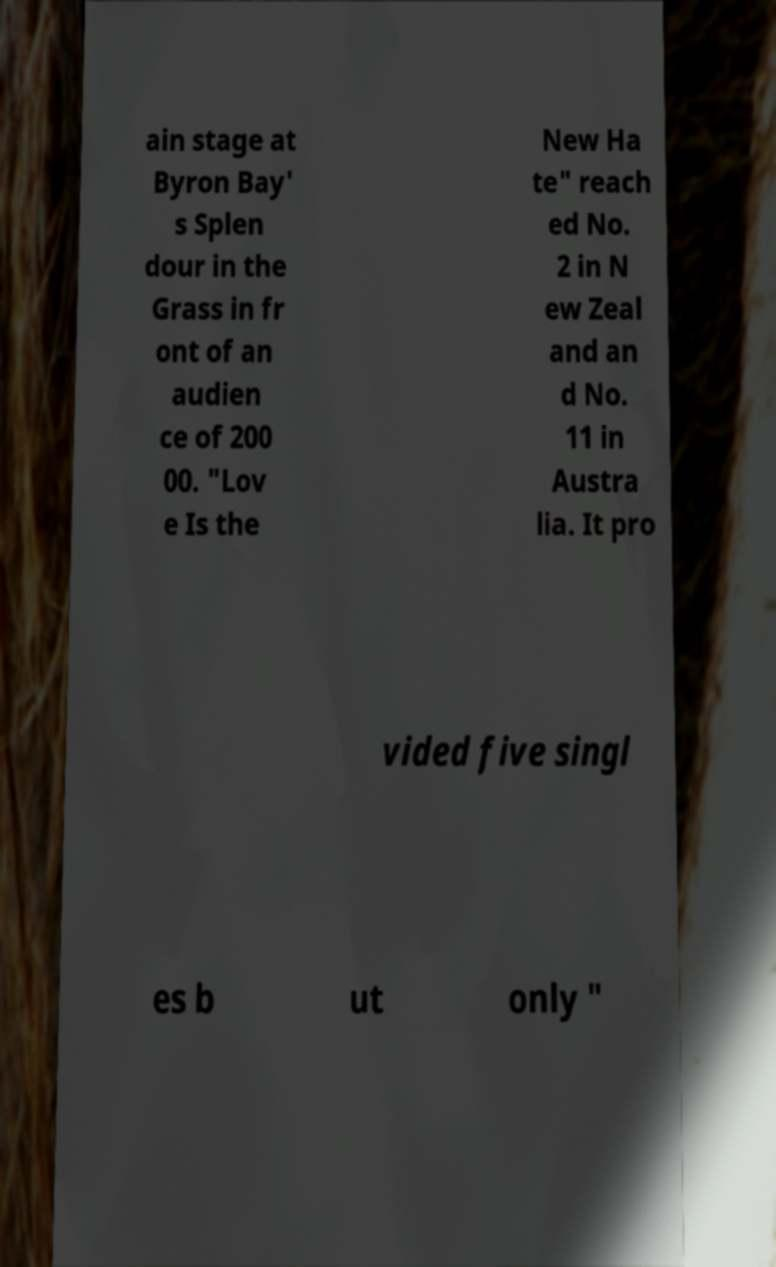For documentation purposes, I need the text within this image transcribed. Could you provide that? ain stage at Byron Bay' s Splen dour in the Grass in fr ont of an audien ce of 200 00. "Lov e Is the New Ha te" reach ed No. 2 in N ew Zeal and an d No. 11 in Austra lia. It pro vided five singl es b ut only " 